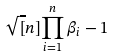<formula> <loc_0><loc_0><loc_500><loc_500>\sqrt { [ } n ] { \prod _ { i = 1 } ^ { n } \beta _ { i } } - 1</formula> 